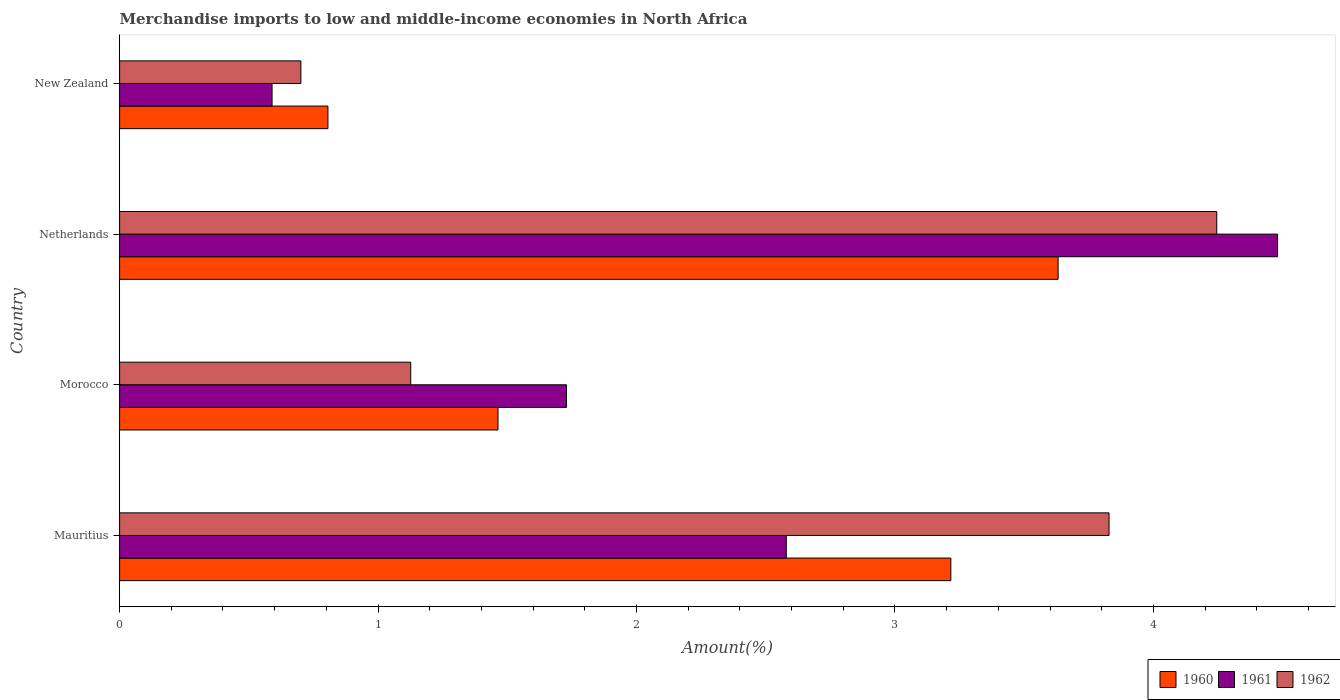How many groups of bars are there?
Provide a succinct answer. 4. Are the number of bars on each tick of the Y-axis equal?
Your answer should be compact. Yes. What is the label of the 3rd group of bars from the top?
Your answer should be compact. Morocco. What is the percentage of amount earned from merchandise imports in 1960 in New Zealand?
Your response must be concise. 0.81. Across all countries, what is the maximum percentage of amount earned from merchandise imports in 1960?
Make the answer very short. 3.63. Across all countries, what is the minimum percentage of amount earned from merchandise imports in 1962?
Provide a short and direct response. 0.7. In which country was the percentage of amount earned from merchandise imports in 1962 maximum?
Provide a succinct answer. Netherlands. In which country was the percentage of amount earned from merchandise imports in 1960 minimum?
Ensure brevity in your answer.  New Zealand. What is the total percentage of amount earned from merchandise imports in 1960 in the graph?
Offer a terse response. 9.12. What is the difference between the percentage of amount earned from merchandise imports in 1960 in Morocco and that in Netherlands?
Offer a very short reply. -2.17. What is the difference between the percentage of amount earned from merchandise imports in 1960 in Netherlands and the percentage of amount earned from merchandise imports in 1962 in Morocco?
Provide a short and direct response. 2.5. What is the average percentage of amount earned from merchandise imports in 1962 per country?
Keep it short and to the point. 2.48. What is the difference between the percentage of amount earned from merchandise imports in 1962 and percentage of amount earned from merchandise imports in 1961 in Mauritius?
Provide a short and direct response. 1.25. What is the ratio of the percentage of amount earned from merchandise imports in 1960 in Morocco to that in Netherlands?
Offer a very short reply. 0.4. Is the difference between the percentage of amount earned from merchandise imports in 1962 in Mauritius and Morocco greater than the difference between the percentage of amount earned from merchandise imports in 1961 in Mauritius and Morocco?
Make the answer very short. Yes. What is the difference between the highest and the second highest percentage of amount earned from merchandise imports in 1960?
Give a very brief answer. 0.42. What is the difference between the highest and the lowest percentage of amount earned from merchandise imports in 1962?
Your answer should be very brief. 3.54. In how many countries, is the percentage of amount earned from merchandise imports in 1960 greater than the average percentage of amount earned from merchandise imports in 1960 taken over all countries?
Your answer should be very brief. 2. Is the sum of the percentage of amount earned from merchandise imports in 1960 in Netherlands and New Zealand greater than the maximum percentage of amount earned from merchandise imports in 1961 across all countries?
Your answer should be compact. No. Is it the case that in every country, the sum of the percentage of amount earned from merchandise imports in 1960 and percentage of amount earned from merchandise imports in 1962 is greater than the percentage of amount earned from merchandise imports in 1961?
Provide a short and direct response. Yes. Are all the bars in the graph horizontal?
Your response must be concise. Yes. How many countries are there in the graph?
Offer a terse response. 4. Where does the legend appear in the graph?
Ensure brevity in your answer.  Bottom right. How many legend labels are there?
Make the answer very short. 3. What is the title of the graph?
Make the answer very short. Merchandise imports to low and middle-income economies in North Africa. Does "1990" appear as one of the legend labels in the graph?
Offer a terse response. No. What is the label or title of the X-axis?
Provide a succinct answer. Amount(%). What is the Amount(%) of 1960 in Mauritius?
Ensure brevity in your answer.  3.22. What is the Amount(%) of 1961 in Mauritius?
Give a very brief answer. 2.58. What is the Amount(%) in 1962 in Mauritius?
Your answer should be compact. 3.83. What is the Amount(%) of 1960 in Morocco?
Offer a terse response. 1.46. What is the Amount(%) in 1961 in Morocco?
Ensure brevity in your answer.  1.73. What is the Amount(%) of 1962 in Morocco?
Provide a short and direct response. 1.13. What is the Amount(%) in 1960 in Netherlands?
Provide a succinct answer. 3.63. What is the Amount(%) of 1961 in Netherlands?
Your answer should be compact. 4.48. What is the Amount(%) of 1962 in Netherlands?
Offer a very short reply. 4.25. What is the Amount(%) of 1960 in New Zealand?
Give a very brief answer. 0.81. What is the Amount(%) in 1961 in New Zealand?
Your answer should be compact. 0.59. What is the Amount(%) of 1962 in New Zealand?
Give a very brief answer. 0.7. Across all countries, what is the maximum Amount(%) of 1960?
Your answer should be compact. 3.63. Across all countries, what is the maximum Amount(%) in 1961?
Your response must be concise. 4.48. Across all countries, what is the maximum Amount(%) of 1962?
Offer a terse response. 4.25. Across all countries, what is the minimum Amount(%) in 1960?
Your response must be concise. 0.81. Across all countries, what is the minimum Amount(%) in 1961?
Provide a succinct answer. 0.59. Across all countries, what is the minimum Amount(%) in 1962?
Make the answer very short. 0.7. What is the total Amount(%) of 1960 in the graph?
Ensure brevity in your answer.  9.12. What is the total Amount(%) in 1961 in the graph?
Provide a short and direct response. 9.38. What is the total Amount(%) of 1962 in the graph?
Make the answer very short. 9.9. What is the difference between the Amount(%) of 1960 in Mauritius and that in Morocco?
Provide a succinct answer. 1.75. What is the difference between the Amount(%) of 1961 in Mauritius and that in Morocco?
Provide a short and direct response. 0.85. What is the difference between the Amount(%) of 1962 in Mauritius and that in Morocco?
Your answer should be very brief. 2.7. What is the difference between the Amount(%) in 1960 in Mauritius and that in Netherlands?
Give a very brief answer. -0.41. What is the difference between the Amount(%) of 1961 in Mauritius and that in Netherlands?
Keep it short and to the point. -1.9. What is the difference between the Amount(%) of 1962 in Mauritius and that in Netherlands?
Offer a very short reply. -0.42. What is the difference between the Amount(%) in 1960 in Mauritius and that in New Zealand?
Make the answer very short. 2.41. What is the difference between the Amount(%) in 1961 in Mauritius and that in New Zealand?
Your response must be concise. 1.99. What is the difference between the Amount(%) in 1962 in Mauritius and that in New Zealand?
Your answer should be very brief. 3.13. What is the difference between the Amount(%) of 1960 in Morocco and that in Netherlands?
Provide a succinct answer. -2.17. What is the difference between the Amount(%) of 1961 in Morocco and that in Netherlands?
Your response must be concise. -2.75. What is the difference between the Amount(%) in 1962 in Morocco and that in Netherlands?
Your answer should be compact. -3.12. What is the difference between the Amount(%) of 1960 in Morocco and that in New Zealand?
Keep it short and to the point. 0.66. What is the difference between the Amount(%) in 1961 in Morocco and that in New Zealand?
Offer a terse response. 1.14. What is the difference between the Amount(%) in 1962 in Morocco and that in New Zealand?
Offer a very short reply. 0.43. What is the difference between the Amount(%) of 1960 in Netherlands and that in New Zealand?
Your answer should be compact. 2.83. What is the difference between the Amount(%) of 1961 in Netherlands and that in New Zealand?
Ensure brevity in your answer.  3.89. What is the difference between the Amount(%) of 1962 in Netherlands and that in New Zealand?
Give a very brief answer. 3.54. What is the difference between the Amount(%) of 1960 in Mauritius and the Amount(%) of 1961 in Morocco?
Provide a succinct answer. 1.49. What is the difference between the Amount(%) of 1960 in Mauritius and the Amount(%) of 1962 in Morocco?
Offer a terse response. 2.09. What is the difference between the Amount(%) of 1961 in Mauritius and the Amount(%) of 1962 in Morocco?
Make the answer very short. 1.45. What is the difference between the Amount(%) in 1960 in Mauritius and the Amount(%) in 1961 in Netherlands?
Your answer should be compact. -1.26. What is the difference between the Amount(%) of 1960 in Mauritius and the Amount(%) of 1962 in Netherlands?
Provide a succinct answer. -1.03. What is the difference between the Amount(%) in 1961 in Mauritius and the Amount(%) in 1962 in Netherlands?
Your response must be concise. -1.67. What is the difference between the Amount(%) in 1960 in Mauritius and the Amount(%) in 1961 in New Zealand?
Provide a short and direct response. 2.63. What is the difference between the Amount(%) of 1960 in Mauritius and the Amount(%) of 1962 in New Zealand?
Ensure brevity in your answer.  2.52. What is the difference between the Amount(%) in 1961 in Mauritius and the Amount(%) in 1962 in New Zealand?
Give a very brief answer. 1.88. What is the difference between the Amount(%) in 1960 in Morocco and the Amount(%) in 1961 in Netherlands?
Keep it short and to the point. -3.02. What is the difference between the Amount(%) of 1960 in Morocco and the Amount(%) of 1962 in Netherlands?
Your answer should be very brief. -2.78. What is the difference between the Amount(%) in 1961 in Morocco and the Amount(%) in 1962 in Netherlands?
Your answer should be compact. -2.52. What is the difference between the Amount(%) in 1960 in Morocco and the Amount(%) in 1961 in New Zealand?
Keep it short and to the point. 0.87. What is the difference between the Amount(%) of 1960 in Morocco and the Amount(%) of 1962 in New Zealand?
Your response must be concise. 0.76. What is the difference between the Amount(%) of 1961 in Morocco and the Amount(%) of 1962 in New Zealand?
Ensure brevity in your answer.  1.03. What is the difference between the Amount(%) of 1960 in Netherlands and the Amount(%) of 1961 in New Zealand?
Offer a terse response. 3.04. What is the difference between the Amount(%) in 1960 in Netherlands and the Amount(%) in 1962 in New Zealand?
Your answer should be very brief. 2.93. What is the difference between the Amount(%) in 1961 in Netherlands and the Amount(%) in 1962 in New Zealand?
Provide a succinct answer. 3.78. What is the average Amount(%) in 1960 per country?
Make the answer very short. 2.28. What is the average Amount(%) of 1961 per country?
Give a very brief answer. 2.34. What is the average Amount(%) of 1962 per country?
Offer a very short reply. 2.48. What is the difference between the Amount(%) in 1960 and Amount(%) in 1961 in Mauritius?
Your answer should be compact. 0.64. What is the difference between the Amount(%) of 1960 and Amount(%) of 1962 in Mauritius?
Make the answer very short. -0.61. What is the difference between the Amount(%) in 1961 and Amount(%) in 1962 in Mauritius?
Offer a very short reply. -1.25. What is the difference between the Amount(%) of 1960 and Amount(%) of 1961 in Morocco?
Keep it short and to the point. -0.27. What is the difference between the Amount(%) in 1960 and Amount(%) in 1962 in Morocco?
Offer a very short reply. 0.34. What is the difference between the Amount(%) of 1961 and Amount(%) of 1962 in Morocco?
Your answer should be very brief. 0.6. What is the difference between the Amount(%) of 1960 and Amount(%) of 1961 in Netherlands?
Ensure brevity in your answer.  -0.85. What is the difference between the Amount(%) of 1960 and Amount(%) of 1962 in Netherlands?
Offer a terse response. -0.61. What is the difference between the Amount(%) in 1961 and Amount(%) in 1962 in Netherlands?
Your answer should be very brief. 0.24. What is the difference between the Amount(%) in 1960 and Amount(%) in 1961 in New Zealand?
Your response must be concise. 0.22. What is the difference between the Amount(%) of 1960 and Amount(%) of 1962 in New Zealand?
Your answer should be compact. 0.1. What is the difference between the Amount(%) in 1961 and Amount(%) in 1962 in New Zealand?
Make the answer very short. -0.11. What is the ratio of the Amount(%) of 1960 in Mauritius to that in Morocco?
Your response must be concise. 2.2. What is the ratio of the Amount(%) in 1961 in Mauritius to that in Morocco?
Your answer should be very brief. 1.49. What is the ratio of the Amount(%) of 1962 in Mauritius to that in Morocco?
Keep it short and to the point. 3.4. What is the ratio of the Amount(%) of 1960 in Mauritius to that in Netherlands?
Your answer should be very brief. 0.89. What is the ratio of the Amount(%) of 1961 in Mauritius to that in Netherlands?
Provide a short and direct response. 0.58. What is the ratio of the Amount(%) of 1962 in Mauritius to that in Netherlands?
Your response must be concise. 0.9. What is the ratio of the Amount(%) of 1960 in Mauritius to that in New Zealand?
Keep it short and to the point. 3.99. What is the ratio of the Amount(%) of 1961 in Mauritius to that in New Zealand?
Ensure brevity in your answer.  4.37. What is the ratio of the Amount(%) of 1962 in Mauritius to that in New Zealand?
Provide a short and direct response. 5.46. What is the ratio of the Amount(%) of 1960 in Morocco to that in Netherlands?
Your answer should be very brief. 0.4. What is the ratio of the Amount(%) in 1961 in Morocco to that in Netherlands?
Keep it short and to the point. 0.39. What is the ratio of the Amount(%) of 1962 in Morocco to that in Netherlands?
Keep it short and to the point. 0.27. What is the ratio of the Amount(%) of 1960 in Morocco to that in New Zealand?
Ensure brevity in your answer.  1.82. What is the ratio of the Amount(%) of 1961 in Morocco to that in New Zealand?
Give a very brief answer. 2.93. What is the ratio of the Amount(%) of 1962 in Morocco to that in New Zealand?
Make the answer very short. 1.61. What is the ratio of the Amount(%) in 1960 in Netherlands to that in New Zealand?
Your answer should be very brief. 4.5. What is the ratio of the Amount(%) of 1961 in Netherlands to that in New Zealand?
Keep it short and to the point. 7.6. What is the ratio of the Amount(%) of 1962 in Netherlands to that in New Zealand?
Ensure brevity in your answer.  6.05. What is the difference between the highest and the second highest Amount(%) of 1960?
Provide a succinct answer. 0.41. What is the difference between the highest and the second highest Amount(%) of 1961?
Offer a terse response. 1.9. What is the difference between the highest and the second highest Amount(%) in 1962?
Give a very brief answer. 0.42. What is the difference between the highest and the lowest Amount(%) of 1960?
Give a very brief answer. 2.83. What is the difference between the highest and the lowest Amount(%) in 1961?
Offer a terse response. 3.89. What is the difference between the highest and the lowest Amount(%) of 1962?
Give a very brief answer. 3.54. 